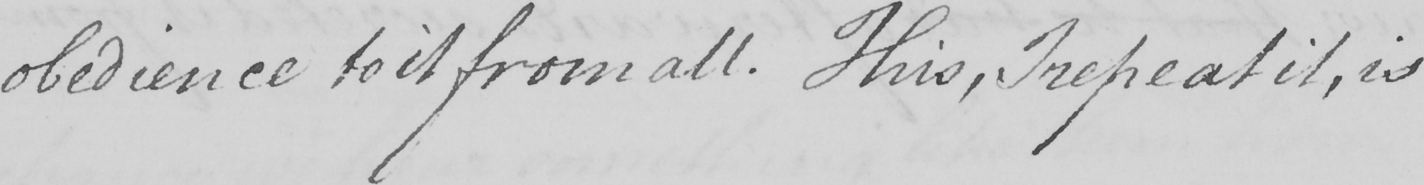What does this handwritten line say? obedience to it from all . This , I repeat it , is 